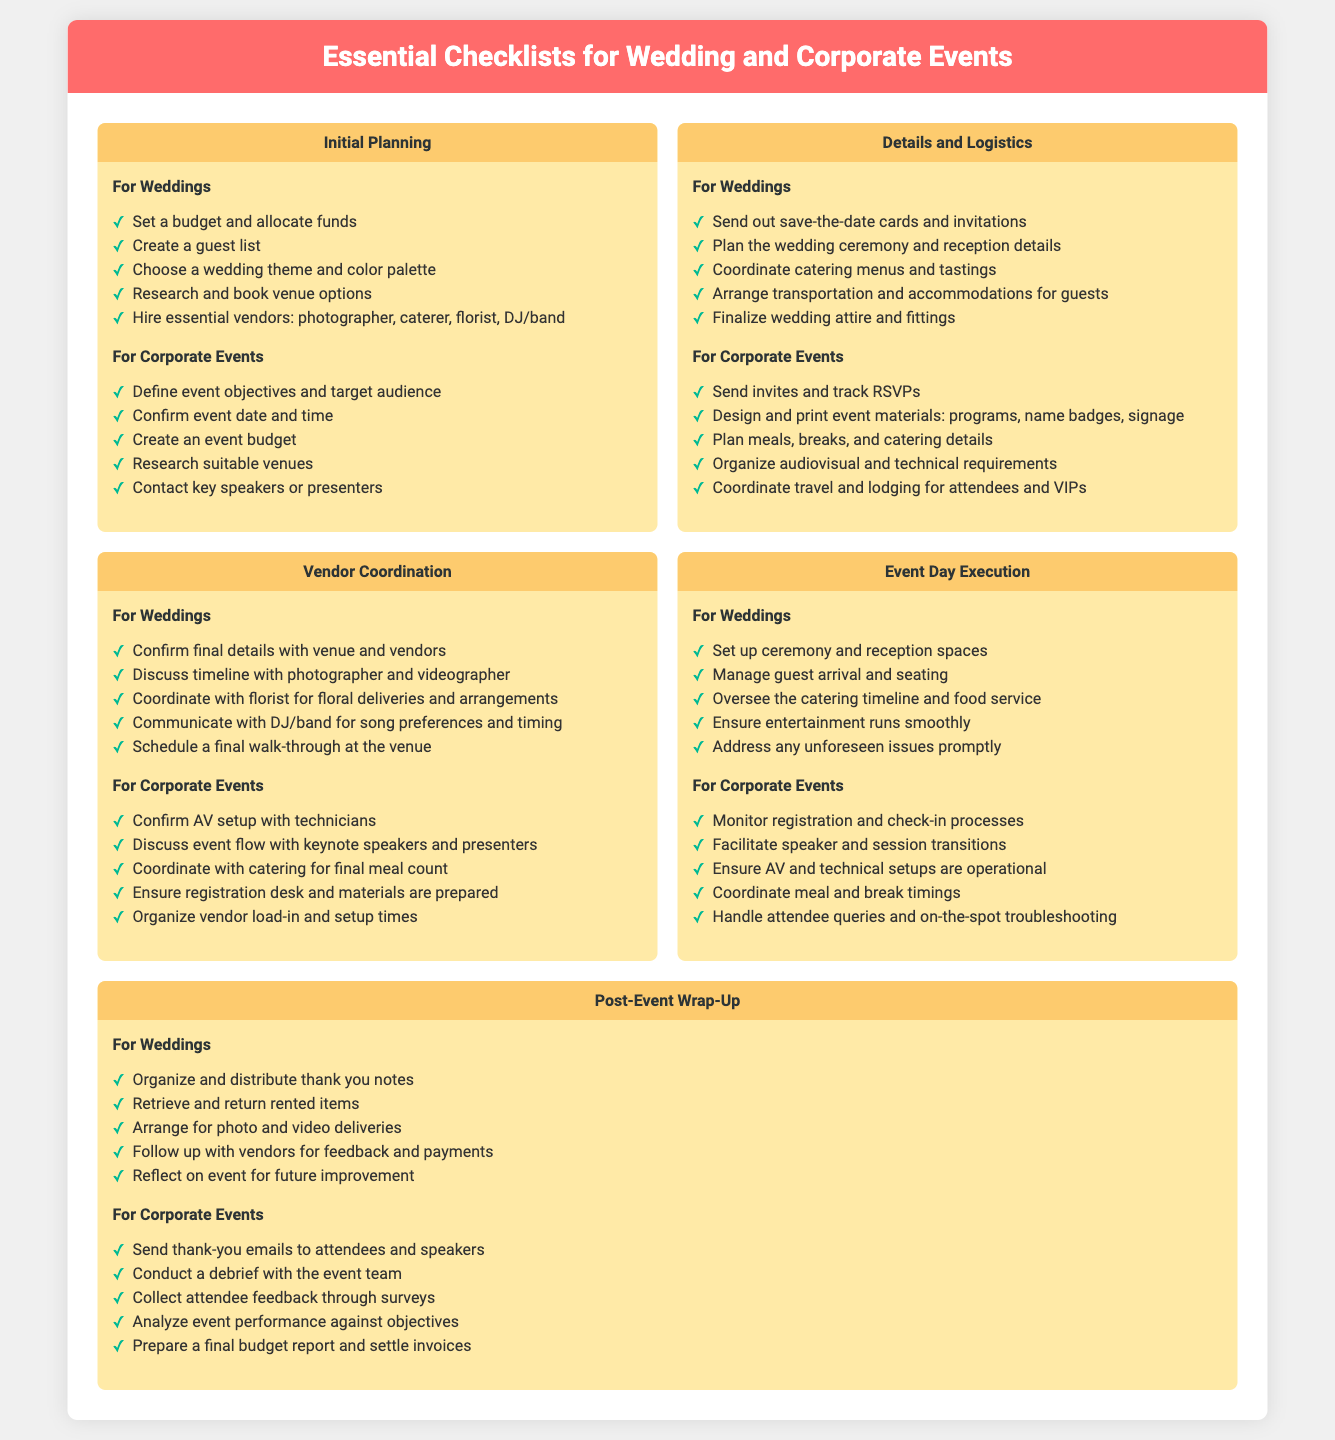what is the first item in the wedding initial planning checklist? The first item listed in the wedding initial planning checklist is to set a budget and allocate funds.
Answer: Set a budget and allocate funds how many sections are in the document? The document consists of six sections, each addressing different aspects of event planning.
Answer: Six what is included in the details and logistics for corporate events? The list includes sending invites, designing materials, planning meals, organizing audiovisual requirements, and coordinating travel.
Answer: Send invites and track RSVPs what is the final step in the post-event wrap-up for weddings? The last item in the post-event wrap-up for weddings is to reflect on the event for future improvement.
Answer: Reflect on event for future improvement which vendor is coordinated for meal count in corporate events? The vendor coordinated for final meal count is catering.
Answer: Catering 